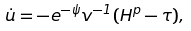Convert formula to latex. <formula><loc_0><loc_0><loc_500><loc_500>\dot { u } = - e ^ { - \psi } v ^ { - 1 } ( H ^ { p } - \tau ) ,</formula> 